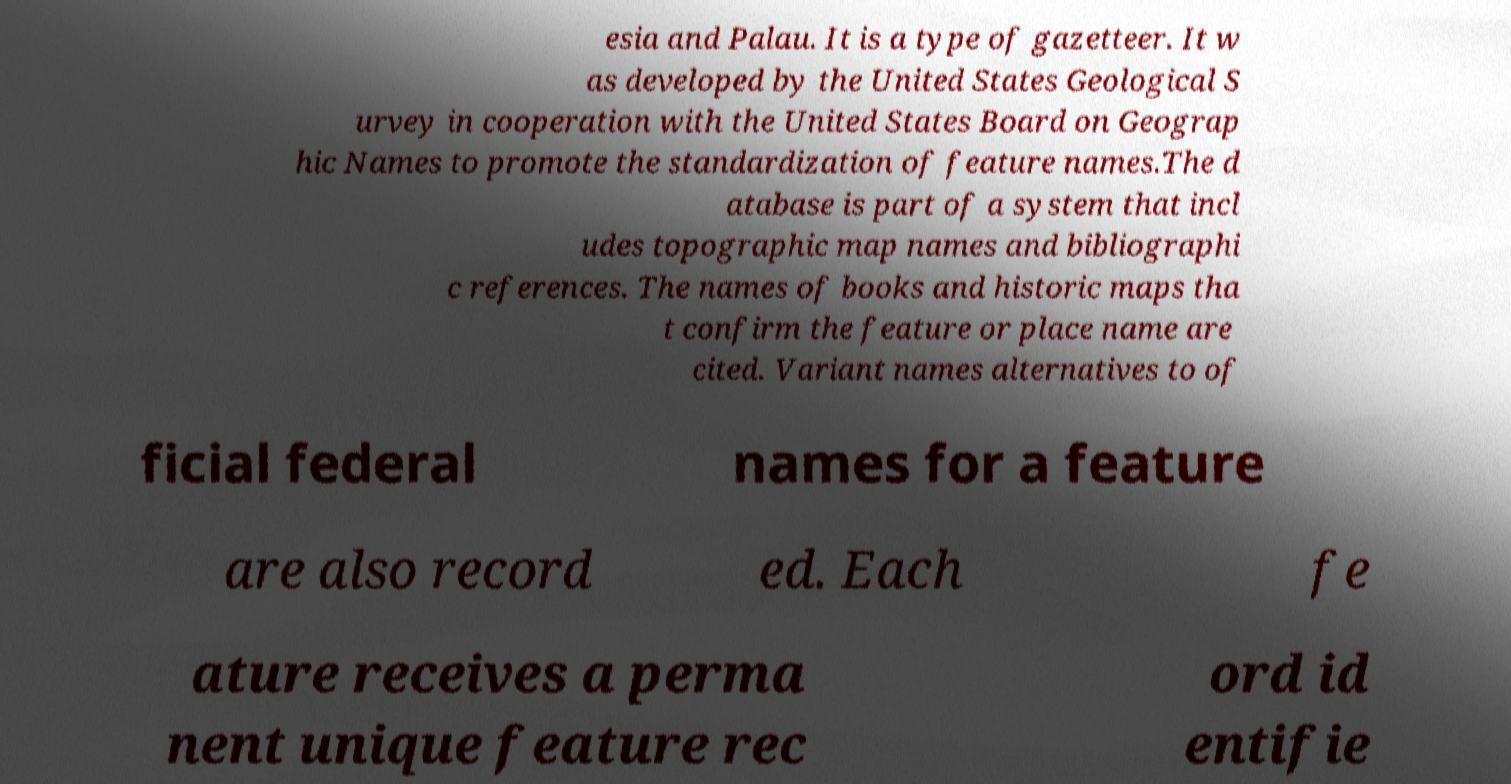I need the written content from this picture converted into text. Can you do that? esia and Palau. It is a type of gazetteer. It w as developed by the United States Geological S urvey in cooperation with the United States Board on Geograp hic Names to promote the standardization of feature names.The d atabase is part of a system that incl udes topographic map names and bibliographi c references. The names of books and historic maps tha t confirm the feature or place name are cited. Variant names alternatives to of ficial federal names for a feature are also record ed. Each fe ature receives a perma nent unique feature rec ord id entifie 